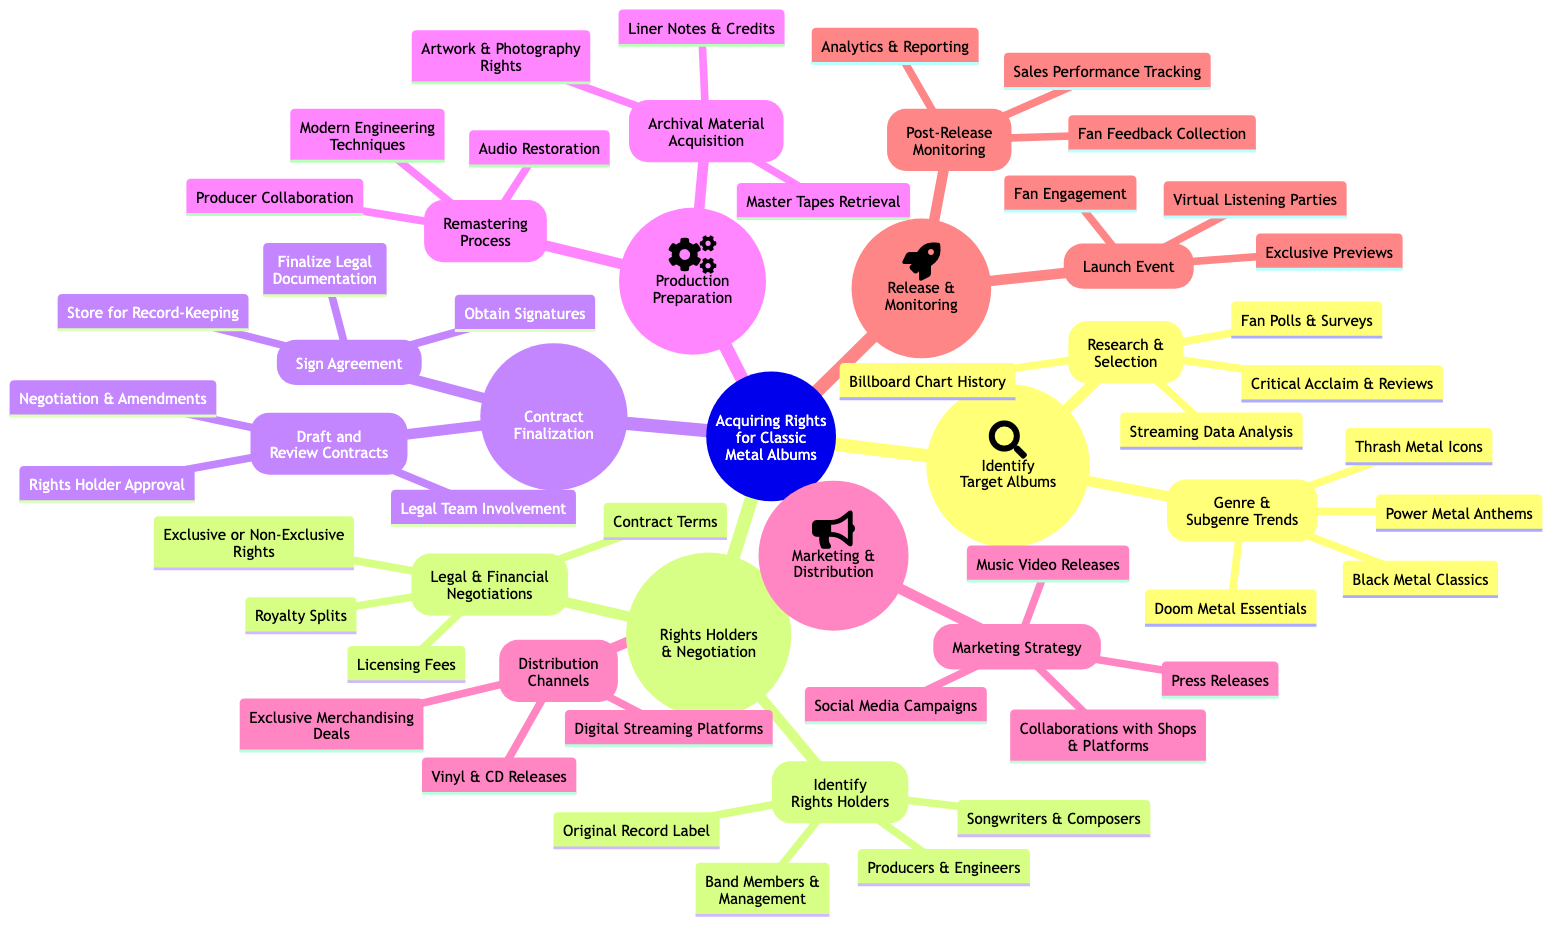What is the first step in acquiring rights for classic metal albums? The first step is "Identify Target Albums," which is the root of the first section in the diagram.
Answer: Identify Target Albums How many categories are there under Rights Holders & Negotiation? There are two categories: "Identify Rights Holders" and "Legal & Financial Negotiations."
Answer: 2 What types of materials need to be acquired in the Production Preparation stage? The materials to be acquired in this stage are listed under "Archival Material Acquisition," which includes "Master Tapes Retrieval," "Artwork & Photography Rights," and "Liner Notes & Credits."
Answer: Archival Material Acquisition Which section includes "Social Media Campaigns"? "Marketing Strategy" is the section that includes "Social Media Campaigns" as part of the marketing efforts for the re-releases.
Answer: Marketing Strategy What is the last step in the process of acquiring rights? The last step shown in the diagram is "Post-Release Monitoring," indicating the actions taken after the album release.
Answer: Post-Release Monitoring Which group is primarily involved in the "Draft and Review Contracts" process? The primary group involved in "Draft and Review Contracts" is "Legal Team Involvement," which is specified under the associated category.
Answer: Legal Team Involvement How many elements are there under the "Launch Event"? There are three elements listed under "Launch Event," which are "Virtual Listening Parties," "Exclusive Previews," and "Fan Engagement."
Answer: 3 Which genre trend includes "Doom Metal Essentials"? "Doom Metal Essentials" is a part of the "Genre & Subgenre Trends" category under "Identify Target Albums."
Answer: Genre & Subgenre Trends What process follows after obtaining signatures in Contract Finalization? After obtaining signatures, the next step is to "Finalize Legal Documentation," which is necessary to complete the contract process.
Answer: Finalize Legal Documentation 